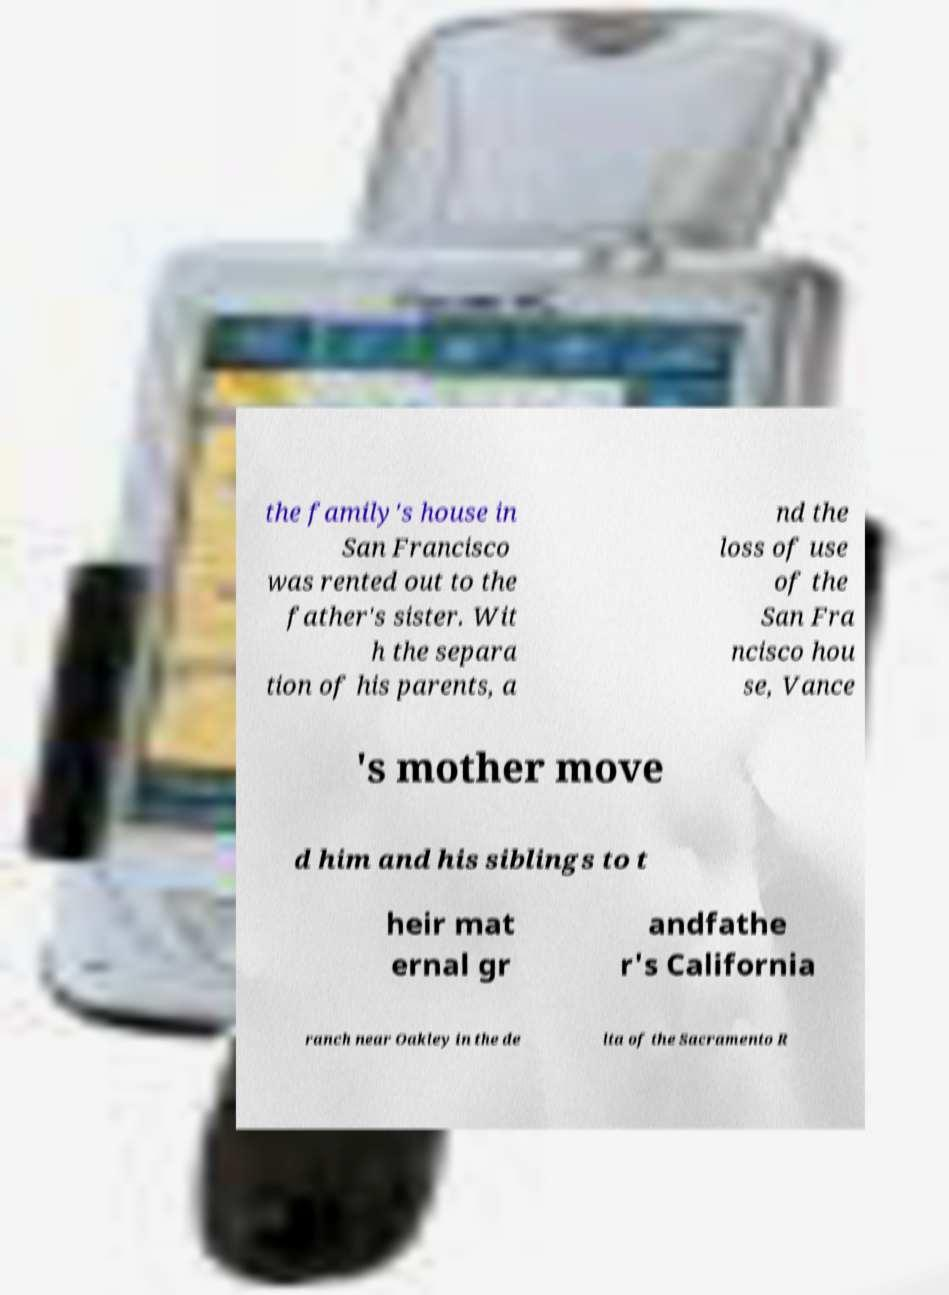For documentation purposes, I need the text within this image transcribed. Could you provide that? the family's house in San Francisco was rented out to the father's sister. Wit h the separa tion of his parents, a nd the loss of use of the San Fra ncisco hou se, Vance 's mother move d him and his siblings to t heir mat ernal gr andfathe r's California ranch near Oakley in the de lta of the Sacramento R 